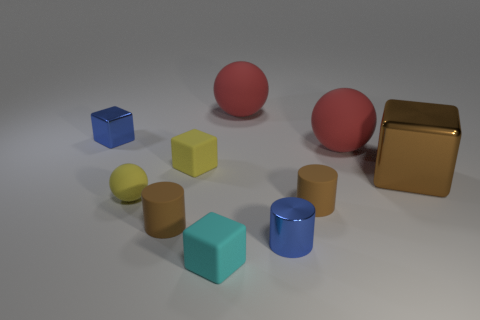There is a ball right of the blue metal cylinder; is its size the same as the blue metallic cube?
Provide a short and direct response. No. Are the tiny blue thing that is behind the big metal thing and the blue thing that is to the right of the small yellow matte sphere made of the same material?
Your answer should be very brief. Yes. Is there a blue metal block that has the same size as the brown cube?
Make the answer very short. No. What is the shape of the brown object that is in front of the brown rubber cylinder to the right of the shiny cylinder in front of the blue cube?
Keep it short and to the point. Cylinder. Are there more small rubber cylinders that are on the left side of the yellow rubber ball than tiny cyan cubes?
Your response must be concise. No. Are there any other brown rubber things that have the same shape as the large brown object?
Your answer should be compact. No. Does the blue block have the same material as the tiny yellow block that is behind the cyan matte block?
Your answer should be compact. No. The big block has what color?
Give a very brief answer. Brown. What number of blue metallic things are behind the yellow rubber object left of the yellow cube that is in front of the small shiny block?
Your response must be concise. 1. There is a yellow sphere; are there any cubes on the right side of it?
Offer a terse response. Yes. 